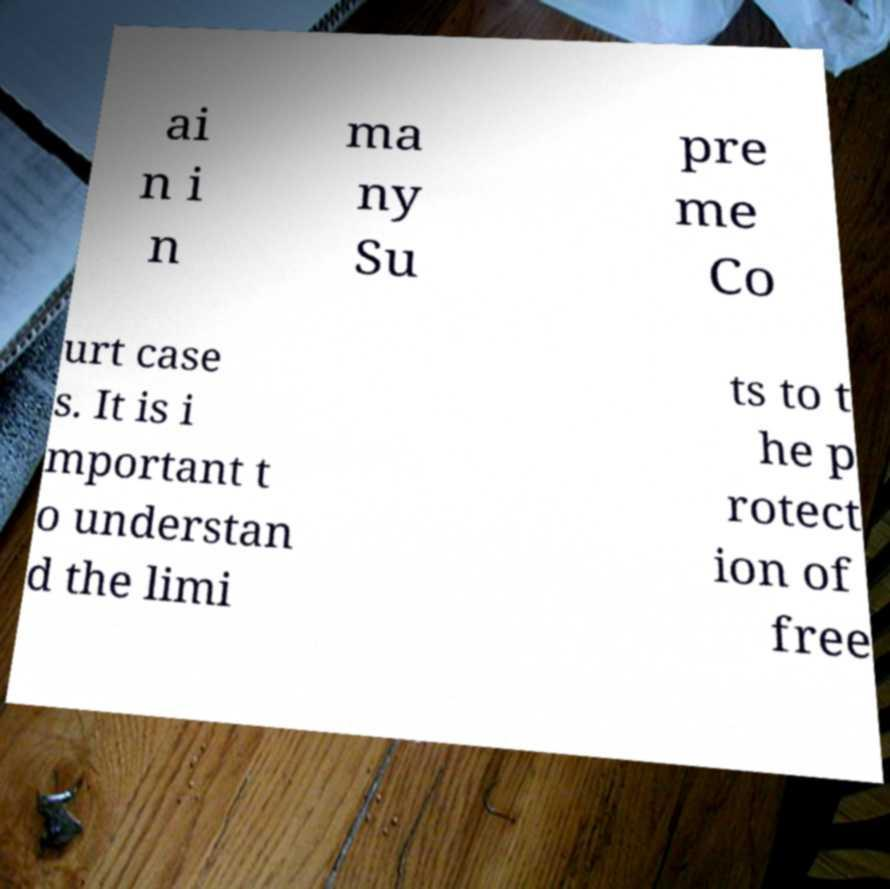Can you accurately transcribe the text from the provided image for me? ai n i n ma ny Su pre me Co urt case s. It is i mportant t o understan d the limi ts to t he p rotect ion of free 